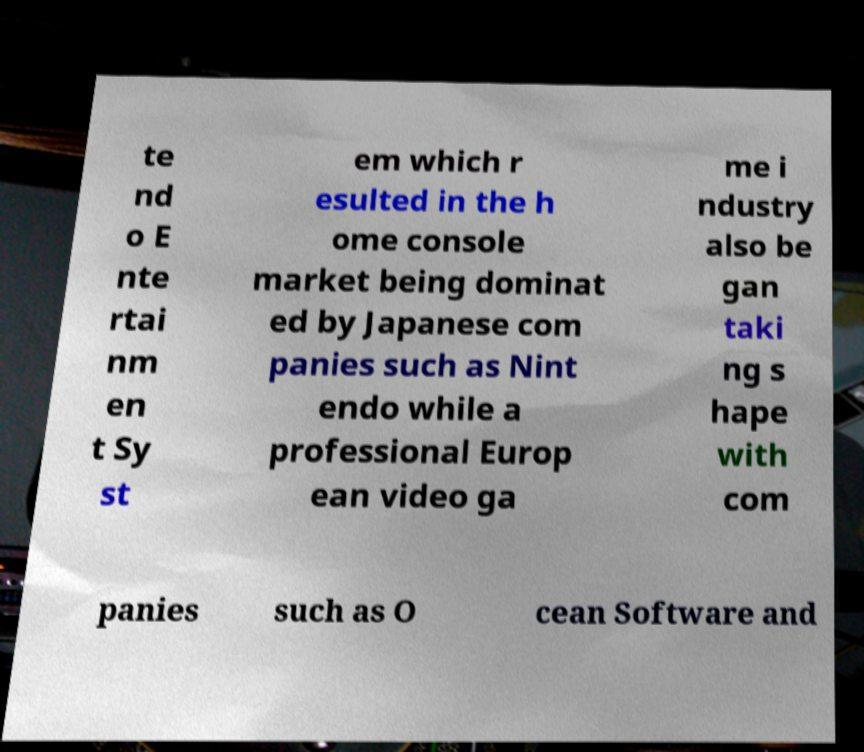Please read and relay the text visible in this image. What does it say? te nd o E nte rtai nm en t Sy st em which r esulted in the h ome console market being dominat ed by Japanese com panies such as Nint endo while a professional Europ ean video ga me i ndustry also be gan taki ng s hape with com panies such as O cean Software and 